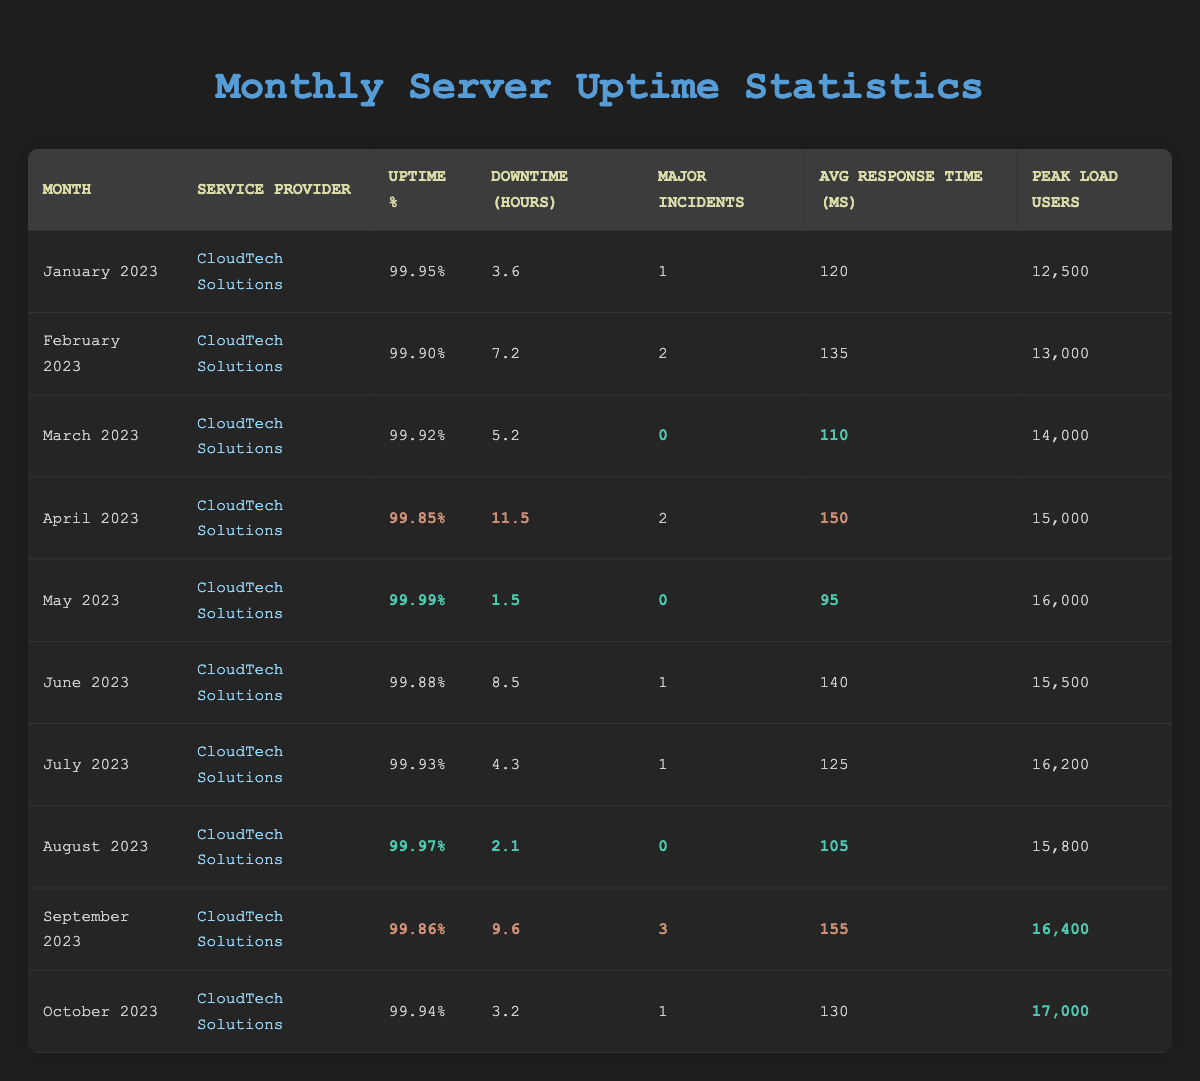What was the uptime percentage for May 2023? In the table, find the row for May 2023, which states that the uptime percentage is 99.99%.
Answer: 99.99% How many major incidents occurred in February 2023? Look at the February 2023 row, which shows that there were 2 major incidents.
Answer: 2 What is the average downtime across all months? To find the average downtime, sum the downtime hours: 3.6 + 7.2 + 5.2 + 11.5 + 1.5 + 8.5 + 4.3 + 2.1 + 9.6 + 3.2 = 53.6 hours. Then divide by 10 months (53.6 / 10 = 5.36).
Answer: 5.36 During which month did CloudTech Solutions have the least downtime? Examine all the rows and identify that May 2023 has the least downtime recorded at 1.5 hours.
Answer: May 2023 Is the average response time in March 2023 lower than in April 2023? Compare the average response times: March has 110 ms and April has 150 ms. Since 110 is less than 150, the statement is true.
Answer: Yes What was the peak load of users in the month with the highest downtime? Review the downtime hours and find that April 2023 has the highest downtime of 11.5 hours with a peak load of 15,000 users.
Answer: 15,000 What percentage of the months had zero major incidents? Out of 10 months, March, May, and August had zero major incidents, which is 3 months. Therefore, the percentage is (3/10) * 100 = 30%.
Answer: 30% Which month showed the biggest improvement in uptime percentage compared to the previous month? Compare the uptime percentages month-over-month: April 99.85% to May 99.99% is an improvement of 0.14%. No other month had a higher improvement percentage when compared to its preceding month.
Answer: May 2023 What is the total number of major incidents recorded from January to October 2023? Sum up the major incidents in each month: 1 + 2 + 0 + 2 + 0 + 1 + 1 + 0 + 3 + 1 = 11.
Answer: 11 Which month had the highest average response time and what was that value? Checking the rows, September has the highest average response time of 155 ms.
Answer: 155 ms 